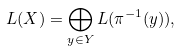<formula> <loc_0><loc_0><loc_500><loc_500>L ( X ) = \bigoplus _ { y \in Y } L ( \pi ^ { - 1 } ( y ) ) ,</formula> 